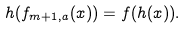<formula> <loc_0><loc_0><loc_500><loc_500>h ( f _ { m + 1 , a } ( x ) ) = f ( h ( x ) ) .</formula> 